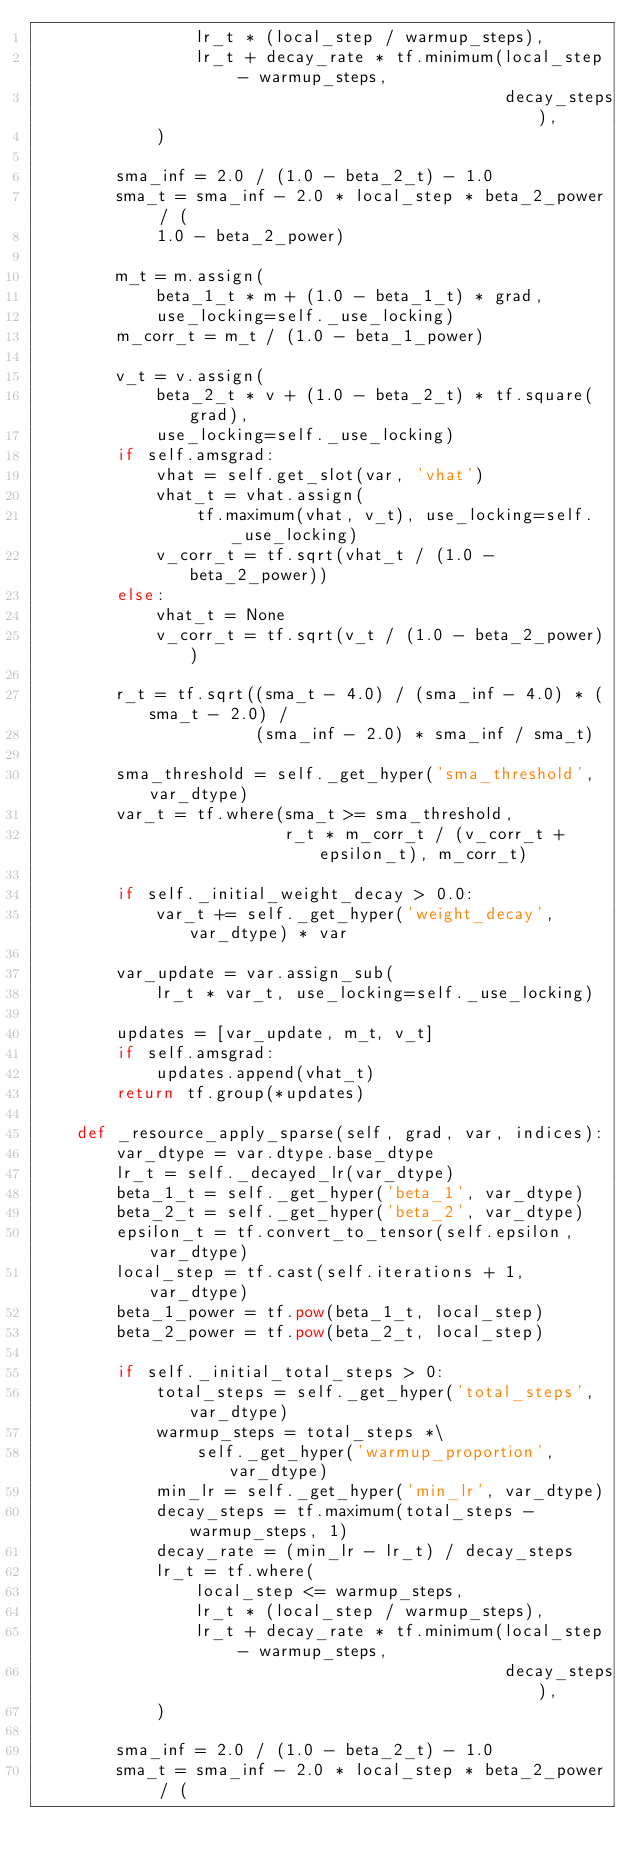<code> <loc_0><loc_0><loc_500><loc_500><_Python_>                lr_t * (local_step / warmup_steps),
                lr_t + decay_rate * tf.minimum(local_step - warmup_steps,
                                               decay_steps),
            )

        sma_inf = 2.0 / (1.0 - beta_2_t) - 1.0
        sma_t = sma_inf - 2.0 * local_step * beta_2_power / (
            1.0 - beta_2_power)

        m_t = m.assign(
            beta_1_t * m + (1.0 - beta_1_t) * grad,
            use_locking=self._use_locking)
        m_corr_t = m_t / (1.0 - beta_1_power)

        v_t = v.assign(
            beta_2_t * v + (1.0 - beta_2_t) * tf.square(grad),
            use_locking=self._use_locking)
        if self.amsgrad:
            vhat = self.get_slot(var, 'vhat')
            vhat_t = vhat.assign(
                tf.maximum(vhat, v_t), use_locking=self._use_locking)
            v_corr_t = tf.sqrt(vhat_t / (1.0 - beta_2_power))
        else:
            vhat_t = None
            v_corr_t = tf.sqrt(v_t / (1.0 - beta_2_power))

        r_t = tf.sqrt((sma_t - 4.0) / (sma_inf - 4.0) * (sma_t - 2.0) /
                      (sma_inf - 2.0) * sma_inf / sma_t)

        sma_threshold = self._get_hyper('sma_threshold', var_dtype)
        var_t = tf.where(sma_t >= sma_threshold,
                         r_t * m_corr_t / (v_corr_t + epsilon_t), m_corr_t)

        if self._initial_weight_decay > 0.0:
            var_t += self._get_hyper('weight_decay', var_dtype) * var

        var_update = var.assign_sub(
            lr_t * var_t, use_locking=self._use_locking)

        updates = [var_update, m_t, v_t]
        if self.amsgrad:
            updates.append(vhat_t)
        return tf.group(*updates)

    def _resource_apply_sparse(self, grad, var, indices):
        var_dtype = var.dtype.base_dtype
        lr_t = self._decayed_lr(var_dtype)
        beta_1_t = self._get_hyper('beta_1', var_dtype)
        beta_2_t = self._get_hyper('beta_2', var_dtype)
        epsilon_t = tf.convert_to_tensor(self.epsilon, var_dtype)
        local_step = tf.cast(self.iterations + 1, var_dtype)
        beta_1_power = tf.pow(beta_1_t, local_step)
        beta_2_power = tf.pow(beta_2_t, local_step)

        if self._initial_total_steps > 0:
            total_steps = self._get_hyper('total_steps', var_dtype)
            warmup_steps = total_steps *\
                self._get_hyper('warmup_proportion', var_dtype)
            min_lr = self._get_hyper('min_lr', var_dtype)
            decay_steps = tf.maximum(total_steps - warmup_steps, 1)
            decay_rate = (min_lr - lr_t) / decay_steps
            lr_t = tf.where(
                local_step <= warmup_steps,
                lr_t * (local_step / warmup_steps),
                lr_t + decay_rate * tf.minimum(local_step - warmup_steps,
                                               decay_steps),
            )

        sma_inf = 2.0 / (1.0 - beta_2_t) - 1.0
        sma_t = sma_inf - 2.0 * local_step * beta_2_power / (</code> 